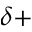<formula> <loc_0><loc_0><loc_500><loc_500>^ { \delta + }</formula> 